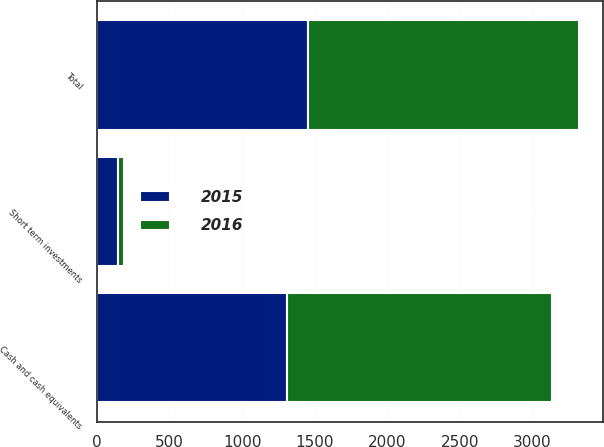Convert chart to OTSL. <chart><loc_0><loc_0><loc_500><loc_500><stacked_bar_chart><ecel><fcel>Cash and cash equivalents<fcel>Short term investments<fcel>Total<nl><fcel>2016<fcel>1820<fcel>43<fcel>1863<nl><fcel>2015<fcel>1311<fcel>144<fcel>1455<nl></chart> 